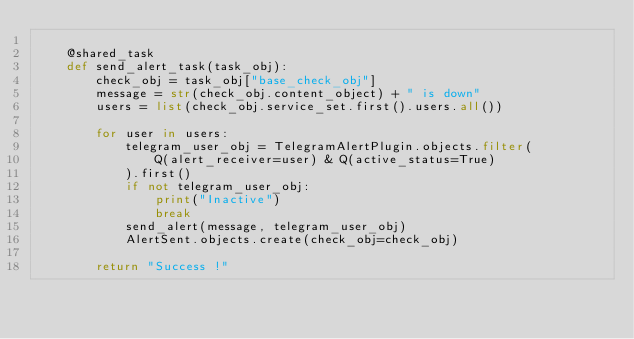<code> <loc_0><loc_0><loc_500><loc_500><_Python_>
    @shared_task
    def send_alert_task(task_obj):
        check_obj = task_obj["base_check_obj"]
        message = str(check_obj.content_object) + " is down"
        users = list(check_obj.service_set.first().users.all())

        for user in users:
            telegram_user_obj = TelegramAlertPlugin.objects.filter(
                Q(alert_receiver=user) & Q(active_status=True)
            ).first()
            if not telegram_user_obj:
                print("Inactive")
                break
            send_alert(message, telegram_user_obj)
            AlertSent.objects.create(check_obj=check_obj)

        return "Success !"
</code> 